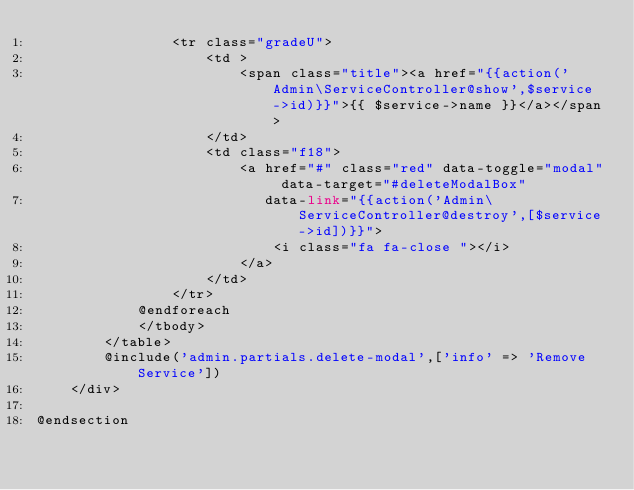Convert code to text. <code><loc_0><loc_0><loc_500><loc_500><_PHP_>                <tr class="gradeU">
                    <td >
                        <span class="title"><a href="{{action('Admin\ServiceController@show',$service->id)}}">{{ $service->name }}</a></span>
                    </td>
                    <td class="f18">
                        <a href="#" class="red" data-toggle="modal" data-target="#deleteModalBox"
                           data-link="{{action('Admin\ServiceController@destroy',[$service->id])}}">
                            <i class="fa fa-close "></i>
                        </a>
                    </td>
                </tr>
            @endforeach
            </tbody>
        </table>
        @include('admin.partials.delete-modal',['info' => 'Remove Service'])
    </div>

@endsection
</code> 